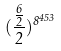<formula> <loc_0><loc_0><loc_500><loc_500>( \frac { \frac { 6 } { 2 } } { 2 } ) ^ { 8 ^ { 4 5 3 } }</formula> 